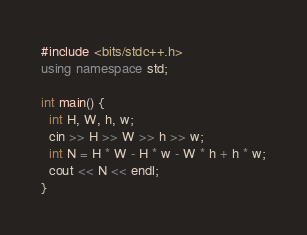Convert code to text. <code><loc_0><loc_0><loc_500><loc_500><_C++_>#include <bits/stdc++.h>
using namespace std;

int main() {
  int H, W, h, w;
  cin >> H >> W >> h >> w;
  int N = H * W - H * w - W * h + h * w;
  cout << N << endl;
}</code> 